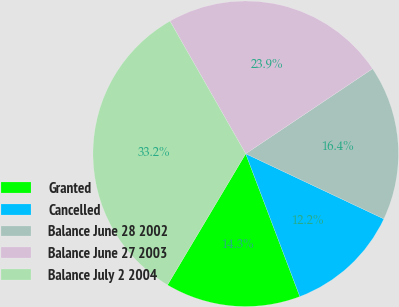Convert chart to OTSL. <chart><loc_0><loc_0><loc_500><loc_500><pie_chart><fcel>Granted<fcel>Cancelled<fcel>Balance June 28 2002<fcel>Balance June 27 2003<fcel>Balance July 2 2004<nl><fcel>14.32%<fcel>12.22%<fcel>16.41%<fcel>23.86%<fcel>33.19%<nl></chart> 